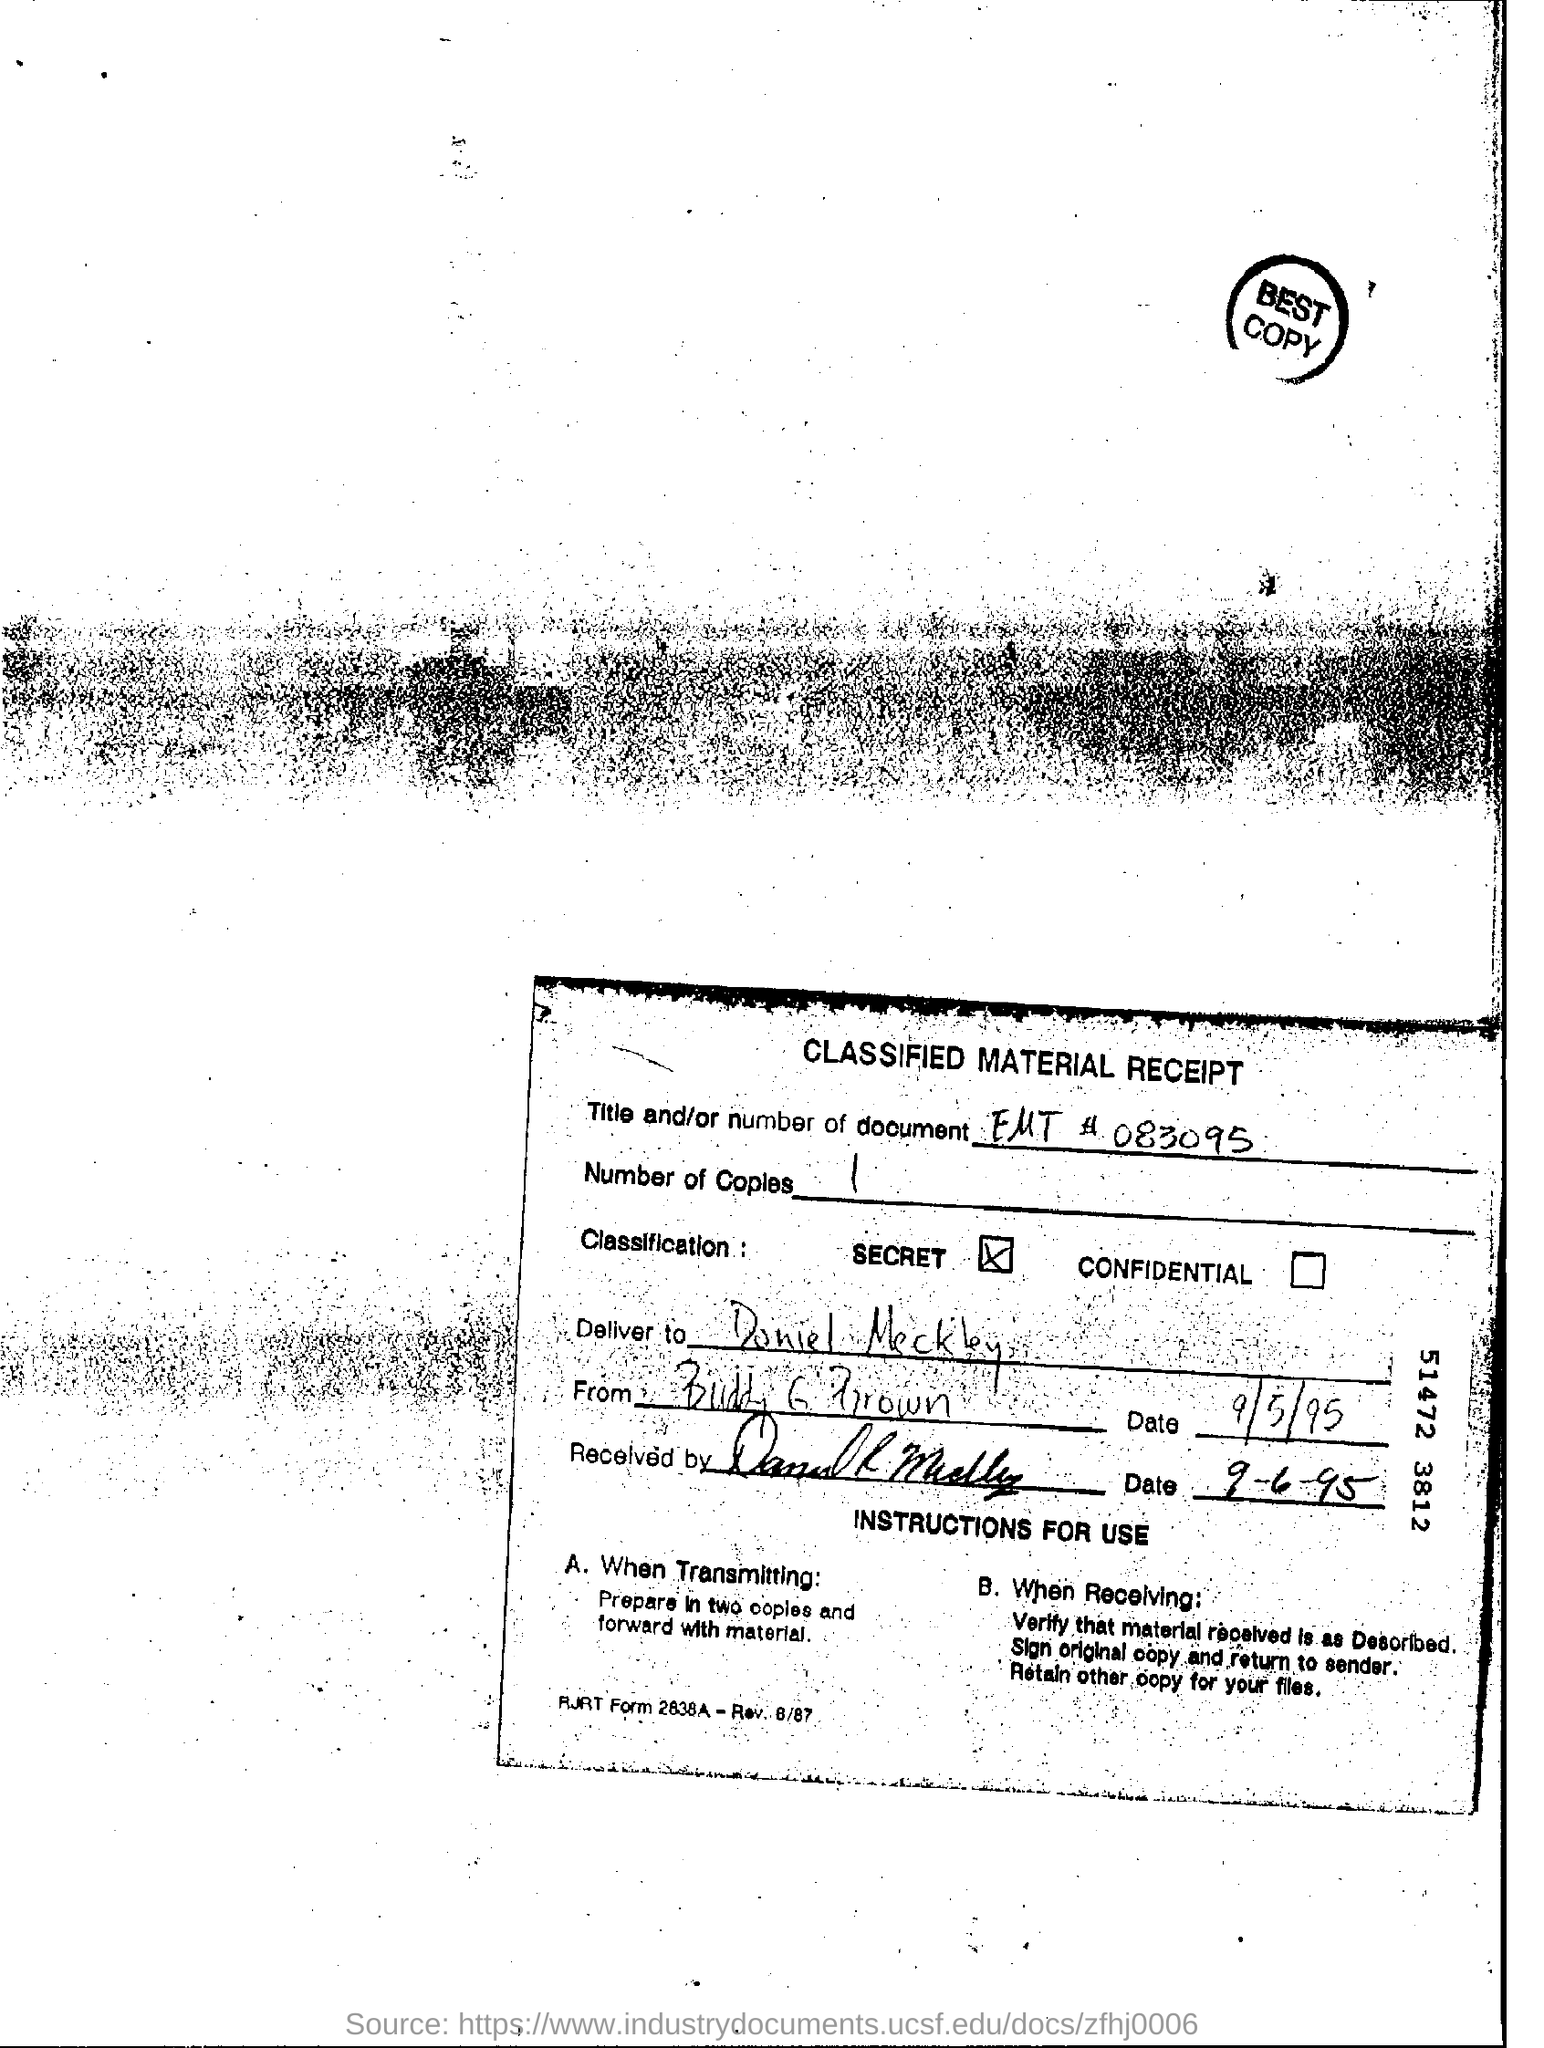Give some essential details in this illustration. The number of copies is one. The title and/or number of the document is EMT #083095. The title of the document is Classified Material Receipt. On what date was the message sent? The message was sent on September 5, 1995. When preparing materials for transmission, it is recommended to make two copies and forward one with the material to ensure its accuracy and reliability. 